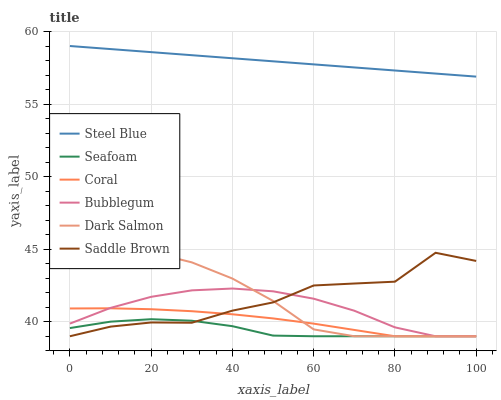Does Coral have the minimum area under the curve?
Answer yes or no. No. Does Coral have the maximum area under the curve?
Answer yes or no. No. Is Coral the smoothest?
Answer yes or no. No. Is Coral the roughest?
Answer yes or no. No. Does Steel Blue have the lowest value?
Answer yes or no. No. Does Coral have the highest value?
Answer yes or no. No. Is Saddle Brown less than Steel Blue?
Answer yes or no. Yes. Is Steel Blue greater than Bubblegum?
Answer yes or no. Yes. Does Saddle Brown intersect Steel Blue?
Answer yes or no. No. 